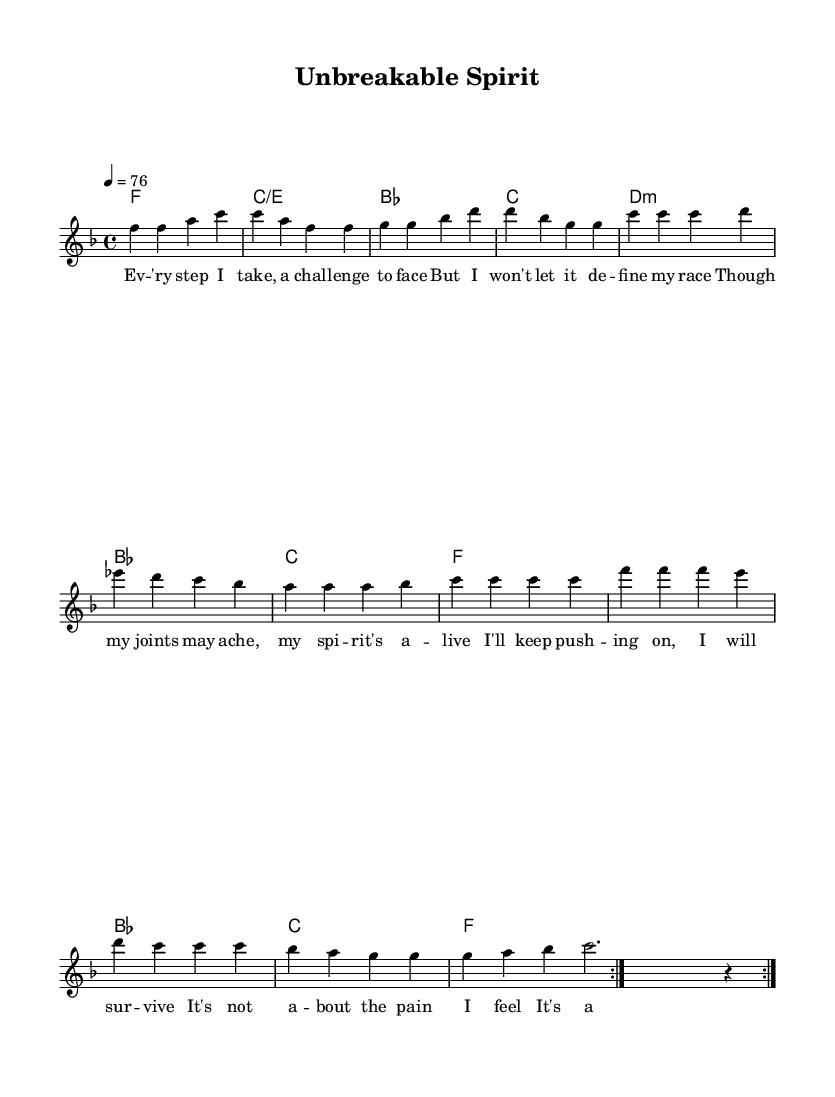What is the key signature of this music? The key signature is F major, which has one flat (B flat). This can be determined from the key signature indicated at the beginning of the music, along with the scale degrees associated with F major.
Answer: F major What is the time signature of this piece? The time signature is 4/4, which is shown at the beginning of the sheet music. This means there are four beats in each measure, and the quarter note gets one beat.
Answer: 4/4 What is the tempo marking of this piece? The tempo marking is 76 beats per minute, shown in the score. This indicates the speed at which the piece should be performed.
Answer: 76 How many times does the melody repeat? The melody repeats two times, as indicated by the "repeat volta 2" notation in the melody section.
Answer: 2 What is the lyrical theme of the song? The theme revolves around resilience and inner strength, particularly in overcoming challenges despite physical pain. This can be deduced from the lyrics provided, which speak to persistence and an unbreakable spirit.
Answer: Resilience What is the first chord in the harmony? The first chord in the harmonic progression is F major. This is seen in the harmonies section, where it starts with the chord F.
Answer: F What musical style does this piece belong to? The piece is categorized as soulful disco, blending soulful melodies with disco rhythms. This is evident from its structure and the emotive themes present in the lyrics.
Answer: Soulful disco 